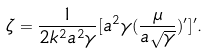<formula> <loc_0><loc_0><loc_500><loc_500>\zeta = \frac { 1 } { 2 k ^ { 2 } a ^ { 2 } \gamma } [ a ^ { 2 } \gamma ( \frac { \mu } { a \sqrt { \gamma } } ) ^ { \prime } ] ^ { \prime } .</formula> 